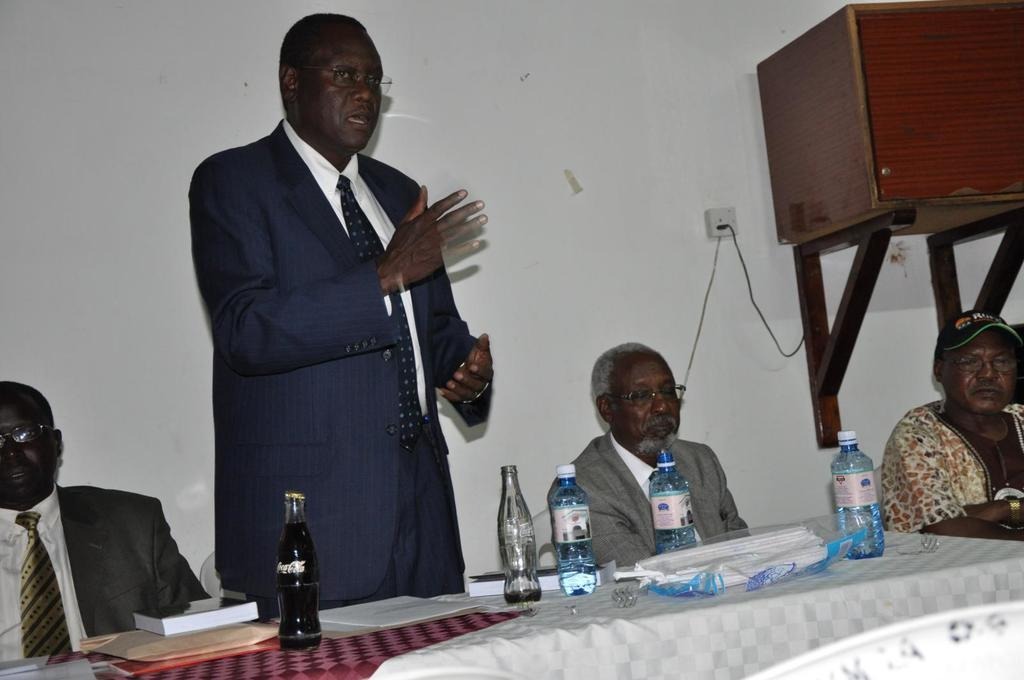What is the man in the image doing? The man is standing and speaking in the image. How many people are seated in the image? There are three people seated in the image. What type of furniture is present in the image? There are chairs in the image. What can be seen on the table in the image? There are bottles on a table in the image. What type of nail is being used to hold the lace in place in the image? There is no nail or lace present in the image. What type of party is being depicted in the image? There is no party depicted in the image; it shows a man standing and speaking, with three people seated nearby. 